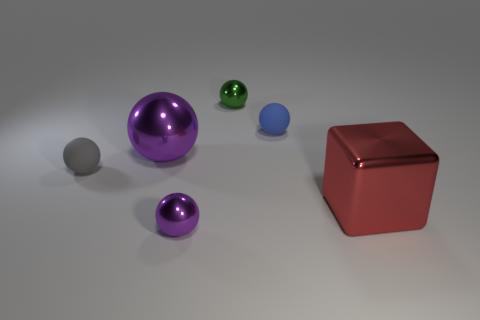What materials are present in the objects in the image? The objects in the image appear to be made of two types of materials: a shiny, reflective metallic finish seen on the large purple sphere, the smaller green sphere, and the red cube; and a matte finish present on the large and small grey spheres and the small blue sphere. Are there any objects that appear to be capable of reflecting light like a mirror? Yes, the large purple sphere, the smaller green sphere, and the red cube exhibit a highly reflective metallic surface that could mirror light much like a mirror would. 